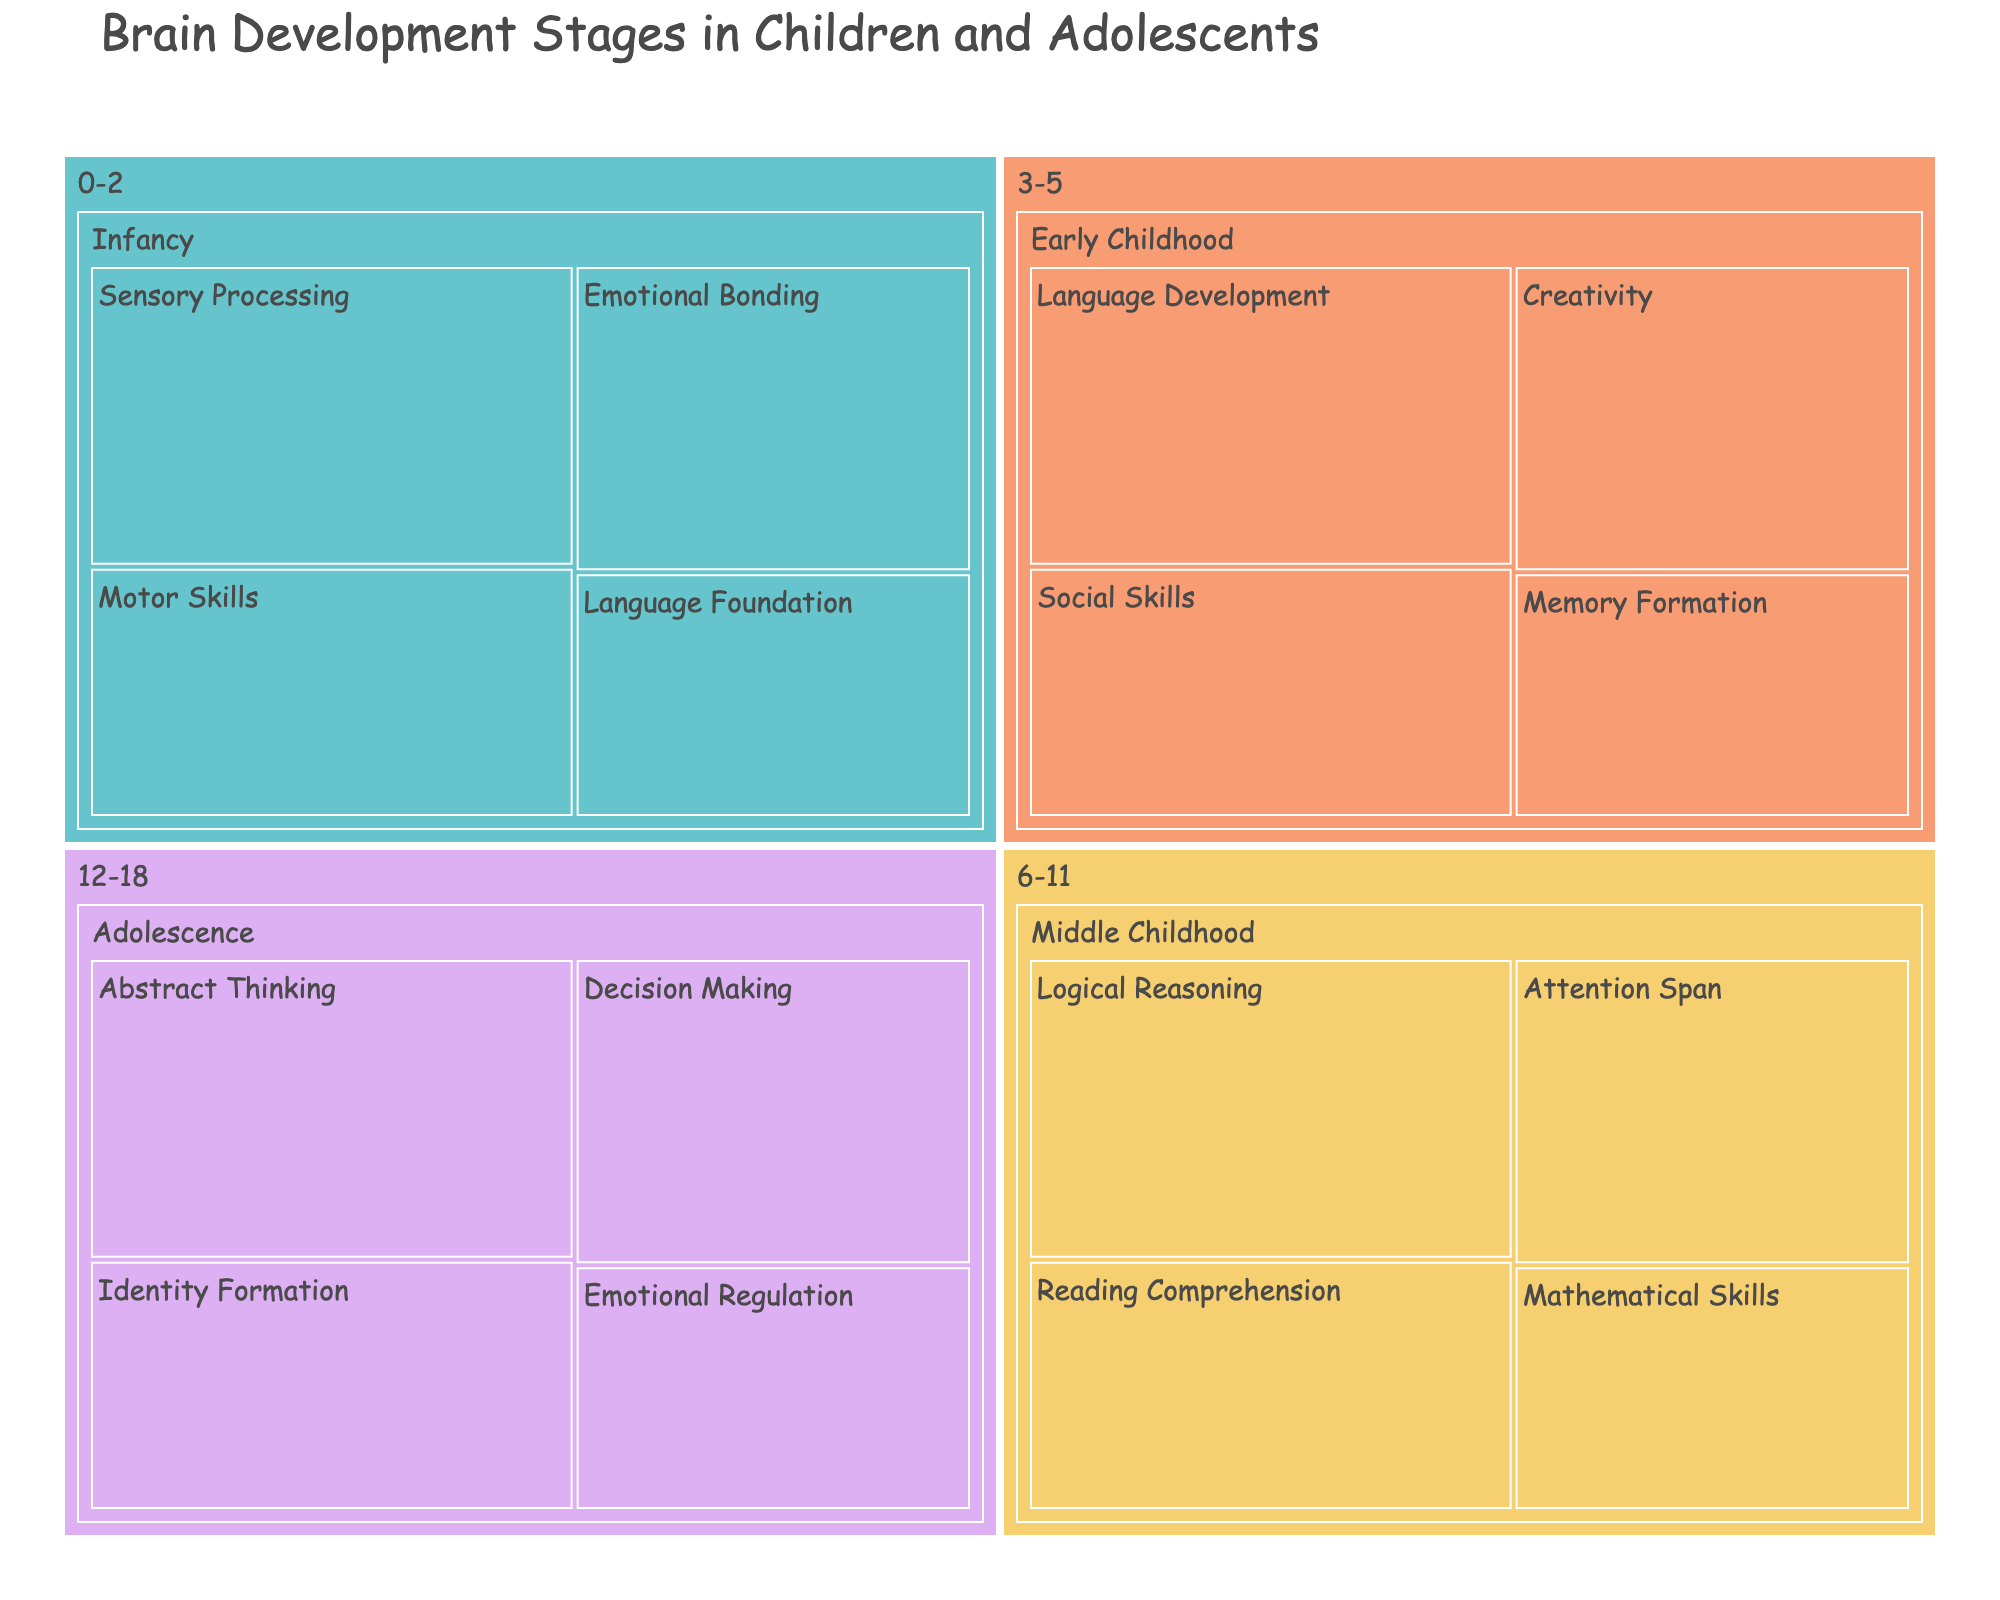What is the title of the treemap? The title of the figure is generally located at the top and is the largest text in the figure. The title in this case clearly states the subject of the treemap.
Answer: Brain Development Stages in Children and Adolescents Which cognitive function is most emphasized in the Infancy stage? To find the most emphasized cognitive function in a stage, look at the percentage values associated with each function. The higher the percentage, the more emphasis it has. In the Infancy stage, Sensory Processing has the highest percentage.
Answer: Sensory Processing What is the total percentage of functions related to the Early Childhood stage? Add up the percentages of all cognitive functions within the Early Childhood stage. The values are 30, 25, 20, and 25. Summing them gives 30 + 25 + 20 + 25.
Answer: 100% Which stage focuses most on Abstract Thinking? Abstract Thinking appears in the Adolescence stage, and you can identify where it falls by looking at the hierarchy in the treemap where Abstract Thinking is grouped.
Answer: Adolescence How does the emphasis on Decision Making in Adolescence compare with Mathematical Skills in Middle Childhood? To compare the emphasis, look at their respective percentages. Decision Making in Adolescence has 25%, while Mathematical Skills in Middle Childhood has 20%. The comparison shows that Decision Making has a higher emphasis.
Answer: Decision Making has a higher emphasis What is the combined percentage for Emotional Bonding in Infancy and Emotional Regulation in Adolescence? Add the percentages of Emotional Bonding in Infancy (25%) and Emotional Regulation in Adolescence (20%). The combined total is 25 + 20.
Answer: 45% Which cognitive function has the equal emphasis in both Infancy and Early Childhood stages? Examine the percentages within both the Infancy and Early Childhood stages to find any matching values. Emotional Bonding in Infancy and Social Skills in Early Childhood both have 25%.
Answer: Equal emphasis is 25% What is the percentage difference between Identity Formation in Adolescence and Creativity in Early Childhood? Subtract the percentage of Creativity in Early Childhood (25%) from Identity Formation in Adolescence (25%). Since their values are the same, the difference is 0%.
Answer: 0% How many cognitive functions are analyzed in total across all stages? Count the distinct cognitive functions listed in the data for all stages. The functions are Sensory Processing, Motor Skills, Language Foundation, Emotional Bonding, Language Development, Social Skills, Memory Formation, Creativity, Logical Reasoning, Reading Comprehension, Mathematical Skills, Attention Span, Abstract Thinking, Decision Making, Emotional Regulation, and Identity Formation. In total, there are 16 functions.
Answer: 16 functions What is the smallest percentage represented in any stage, and which function does it correspond to? Scan through all the percentage values to find the smallest one, which is 20%. Then identify the cognitive functions that correspond to this value. There are several with 20%: Language Foundation in Infancy, Memory Formation in Early Childhood, Mathematical Skills in Middle Childhood, and Emotional Regulation in Adolescence.
Answer: 20%, multiple functions 